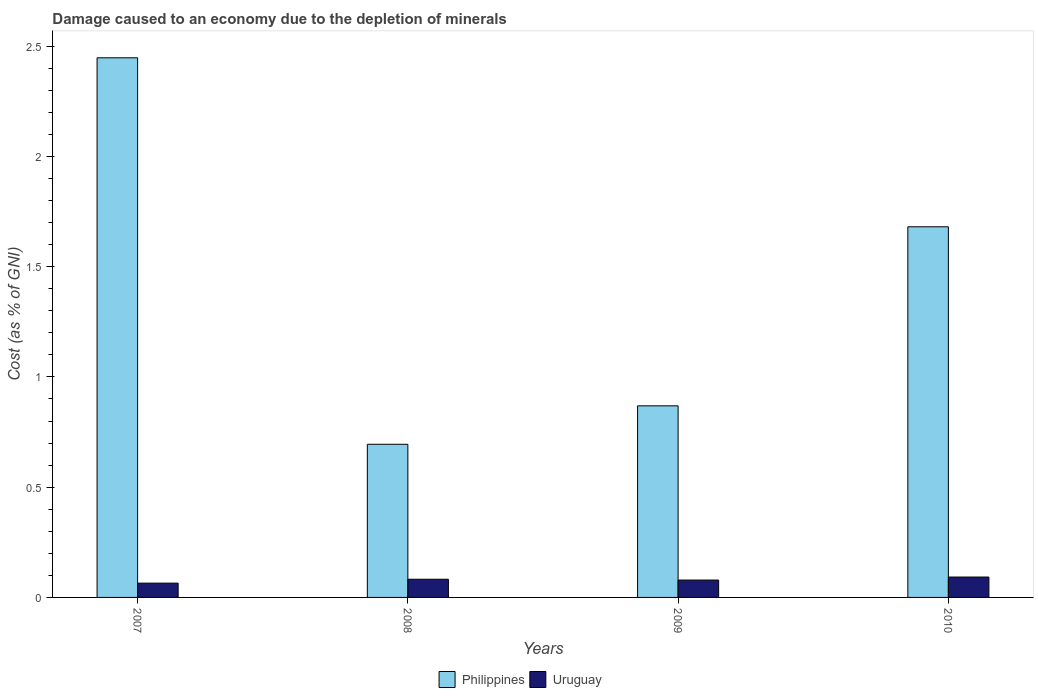How many bars are there on the 1st tick from the left?
Your answer should be compact. 2. What is the label of the 3rd group of bars from the left?
Give a very brief answer. 2009. What is the cost of damage caused due to the depletion of minerals in Philippines in 2007?
Offer a terse response. 2.45. Across all years, what is the maximum cost of damage caused due to the depletion of minerals in Philippines?
Ensure brevity in your answer.  2.45. Across all years, what is the minimum cost of damage caused due to the depletion of minerals in Uruguay?
Your answer should be compact. 0.06. In which year was the cost of damage caused due to the depletion of minerals in Uruguay minimum?
Provide a short and direct response. 2007. What is the total cost of damage caused due to the depletion of minerals in Philippines in the graph?
Keep it short and to the point. 5.69. What is the difference between the cost of damage caused due to the depletion of minerals in Philippines in 2008 and that in 2009?
Offer a very short reply. -0.17. What is the difference between the cost of damage caused due to the depletion of minerals in Philippines in 2007 and the cost of damage caused due to the depletion of minerals in Uruguay in 2009?
Provide a short and direct response. 2.37. What is the average cost of damage caused due to the depletion of minerals in Uruguay per year?
Provide a succinct answer. 0.08. In the year 2007, what is the difference between the cost of damage caused due to the depletion of minerals in Philippines and cost of damage caused due to the depletion of minerals in Uruguay?
Keep it short and to the point. 2.38. In how many years, is the cost of damage caused due to the depletion of minerals in Uruguay greater than 1 %?
Your response must be concise. 0. What is the ratio of the cost of damage caused due to the depletion of minerals in Uruguay in 2007 to that in 2008?
Your answer should be compact. 0.79. Is the difference between the cost of damage caused due to the depletion of minerals in Philippines in 2007 and 2009 greater than the difference between the cost of damage caused due to the depletion of minerals in Uruguay in 2007 and 2009?
Your answer should be very brief. Yes. What is the difference between the highest and the second highest cost of damage caused due to the depletion of minerals in Philippines?
Your answer should be compact. 0.77. What is the difference between the highest and the lowest cost of damage caused due to the depletion of minerals in Uruguay?
Keep it short and to the point. 0.03. What does the 1st bar from the right in 2008 represents?
Make the answer very short. Uruguay. Are all the bars in the graph horizontal?
Your answer should be very brief. No. How many years are there in the graph?
Your answer should be very brief. 4. Does the graph contain any zero values?
Keep it short and to the point. No. How are the legend labels stacked?
Offer a very short reply. Horizontal. What is the title of the graph?
Offer a very short reply. Damage caused to an economy due to the depletion of minerals. What is the label or title of the X-axis?
Ensure brevity in your answer.  Years. What is the label or title of the Y-axis?
Give a very brief answer. Cost (as % of GNI). What is the Cost (as % of GNI) of Philippines in 2007?
Give a very brief answer. 2.45. What is the Cost (as % of GNI) in Uruguay in 2007?
Your response must be concise. 0.06. What is the Cost (as % of GNI) in Philippines in 2008?
Provide a succinct answer. 0.69. What is the Cost (as % of GNI) of Uruguay in 2008?
Provide a succinct answer. 0.08. What is the Cost (as % of GNI) in Philippines in 2009?
Ensure brevity in your answer.  0.87. What is the Cost (as % of GNI) in Uruguay in 2009?
Your answer should be compact. 0.08. What is the Cost (as % of GNI) of Philippines in 2010?
Your response must be concise. 1.68. What is the Cost (as % of GNI) in Uruguay in 2010?
Keep it short and to the point. 0.09. Across all years, what is the maximum Cost (as % of GNI) in Philippines?
Offer a terse response. 2.45. Across all years, what is the maximum Cost (as % of GNI) of Uruguay?
Your answer should be compact. 0.09. Across all years, what is the minimum Cost (as % of GNI) of Philippines?
Make the answer very short. 0.69. Across all years, what is the minimum Cost (as % of GNI) in Uruguay?
Keep it short and to the point. 0.06. What is the total Cost (as % of GNI) of Philippines in the graph?
Offer a very short reply. 5.69. What is the total Cost (as % of GNI) of Uruguay in the graph?
Your answer should be compact. 0.32. What is the difference between the Cost (as % of GNI) in Philippines in 2007 and that in 2008?
Offer a very short reply. 1.75. What is the difference between the Cost (as % of GNI) of Uruguay in 2007 and that in 2008?
Offer a terse response. -0.02. What is the difference between the Cost (as % of GNI) in Philippines in 2007 and that in 2009?
Provide a succinct answer. 1.58. What is the difference between the Cost (as % of GNI) in Uruguay in 2007 and that in 2009?
Your answer should be compact. -0.01. What is the difference between the Cost (as % of GNI) in Philippines in 2007 and that in 2010?
Offer a terse response. 0.77. What is the difference between the Cost (as % of GNI) of Uruguay in 2007 and that in 2010?
Keep it short and to the point. -0.03. What is the difference between the Cost (as % of GNI) in Philippines in 2008 and that in 2009?
Give a very brief answer. -0.17. What is the difference between the Cost (as % of GNI) in Uruguay in 2008 and that in 2009?
Your answer should be compact. 0. What is the difference between the Cost (as % of GNI) of Philippines in 2008 and that in 2010?
Your answer should be very brief. -0.99. What is the difference between the Cost (as % of GNI) in Uruguay in 2008 and that in 2010?
Your answer should be compact. -0.01. What is the difference between the Cost (as % of GNI) of Philippines in 2009 and that in 2010?
Your answer should be compact. -0.81. What is the difference between the Cost (as % of GNI) of Uruguay in 2009 and that in 2010?
Make the answer very short. -0.01. What is the difference between the Cost (as % of GNI) in Philippines in 2007 and the Cost (as % of GNI) in Uruguay in 2008?
Provide a succinct answer. 2.36. What is the difference between the Cost (as % of GNI) in Philippines in 2007 and the Cost (as % of GNI) in Uruguay in 2009?
Your response must be concise. 2.37. What is the difference between the Cost (as % of GNI) in Philippines in 2007 and the Cost (as % of GNI) in Uruguay in 2010?
Give a very brief answer. 2.35. What is the difference between the Cost (as % of GNI) of Philippines in 2008 and the Cost (as % of GNI) of Uruguay in 2009?
Your response must be concise. 0.62. What is the difference between the Cost (as % of GNI) of Philippines in 2008 and the Cost (as % of GNI) of Uruguay in 2010?
Ensure brevity in your answer.  0.6. What is the difference between the Cost (as % of GNI) of Philippines in 2009 and the Cost (as % of GNI) of Uruguay in 2010?
Your response must be concise. 0.78. What is the average Cost (as % of GNI) in Philippines per year?
Make the answer very short. 1.42. What is the average Cost (as % of GNI) of Uruguay per year?
Your response must be concise. 0.08. In the year 2007, what is the difference between the Cost (as % of GNI) of Philippines and Cost (as % of GNI) of Uruguay?
Your answer should be compact. 2.38. In the year 2008, what is the difference between the Cost (as % of GNI) of Philippines and Cost (as % of GNI) of Uruguay?
Your response must be concise. 0.61. In the year 2009, what is the difference between the Cost (as % of GNI) of Philippines and Cost (as % of GNI) of Uruguay?
Provide a succinct answer. 0.79. In the year 2010, what is the difference between the Cost (as % of GNI) in Philippines and Cost (as % of GNI) in Uruguay?
Your answer should be compact. 1.59. What is the ratio of the Cost (as % of GNI) of Philippines in 2007 to that in 2008?
Your response must be concise. 3.52. What is the ratio of the Cost (as % of GNI) in Uruguay in 2007 to that in 2008?
Your response must be concise. 0.79. What is the ratio of the Cost (as % of GNI) in Philippines in 2007 to that in 2009?
Your answer should be very brief. 2.82. What is the ratio of the Cost (as % of GNI) in Uruguay in 2007 to that in 2009?
Provide a short and direct response. 0.82. What is the ratio of the Cost (as % of GNI) of Philippines in 2007 to that in 2010?
Offer a very short reply. 1.46. What is the ratio of the Cost (as % of GNI) in Uruguay in 2007 to that in 2010?
Your answer should be very brief. 0.7. What is the ratio of the Cost (as % of GNI) of Philippines in 2008 to that in 2009?
Provide a short and direct response. 0.8. What is the ratio of the Cost (as % of GNI) in Uruguay in 2008 to that in 2009?
Provide a short and direct response. 1.05. What is the ratio of the Cost (as % of GNI) of Philippines in 2008 to that in 2010?
Your answer should be very brief. 0.41. What is the ratio of the Cost (as % of GNI) of Uruguay in 2008 to that in 2010?
Make the answer very short. 0.89. What is the ratio of the Cost (as % of GNI) of Philippines in 2009 to that in 2010?
Your answer should be compact. 0.52. What is the ratio of the Cost (as % of GNI) in Uruguay in 2009 to that in 2010?
Provide a succinct answer. 0.85. What is the difference between the highest and the second highest Cost (as % of GNI) of Philippines?
Your answer should be compact. 0.77. What is the difference between the highest and the lowest Cost (as % of GNI) in Philippines?
Keep it short and to the point. 1.75. What is the difference between the highest and the lowest Cost (as % of GNI) in Uruguay?
Offer a very short reply. 0.03. 